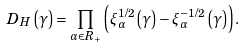Convert formula to latex. <formula><loc_0><loc_0><loc_500><loc_500>D _ { H } \left ( \gamma \right ) = \prod _ { \alpha \in R _ { + } } \left ( \xi _ { \alpha } ^ { 1 / 2 } \left ( \gamma \right ) - \xi _ { \alpha } ^ { - 1 / 2 } \left ( \gamma \right ) \right ) .</formula> 